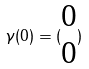<formula> <loc_0><loc_0><loc_500><loc_500>\gamma ( 0 ) = ( \begin{matrix} 0 \\ 0 \end{matrix} )</formula> 